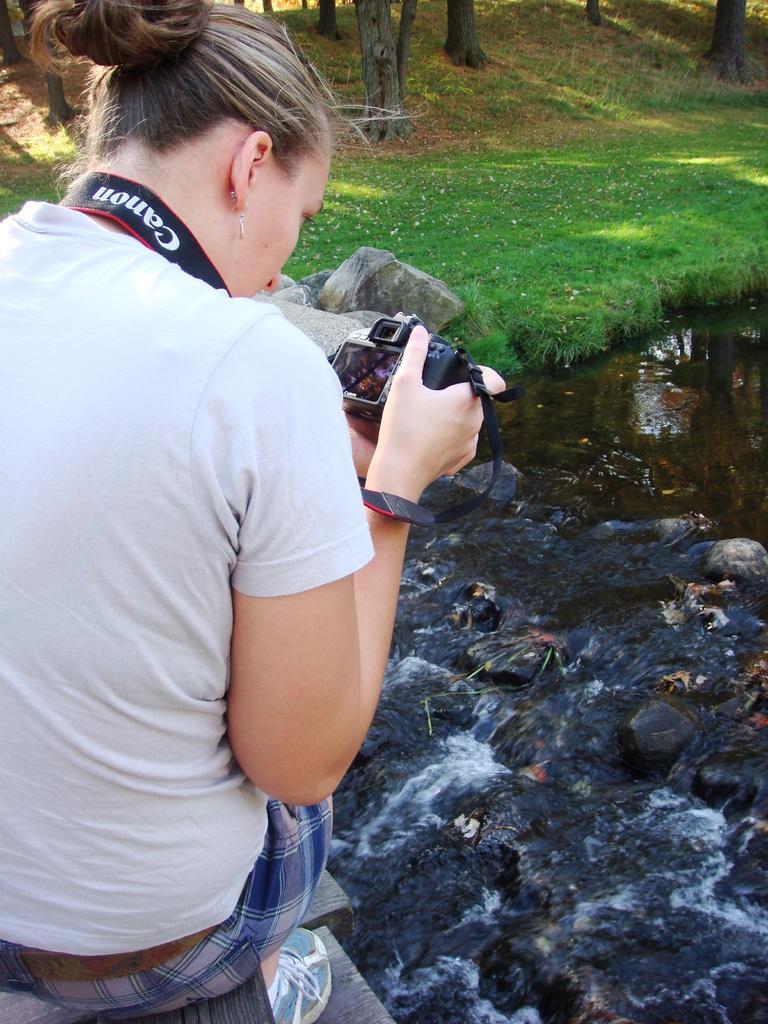Could you give a brief overview of what you see in this image? This woman is sitting and capturing a picture of a floating water. She is holding a camera. Grass is in green color. This are trees. 